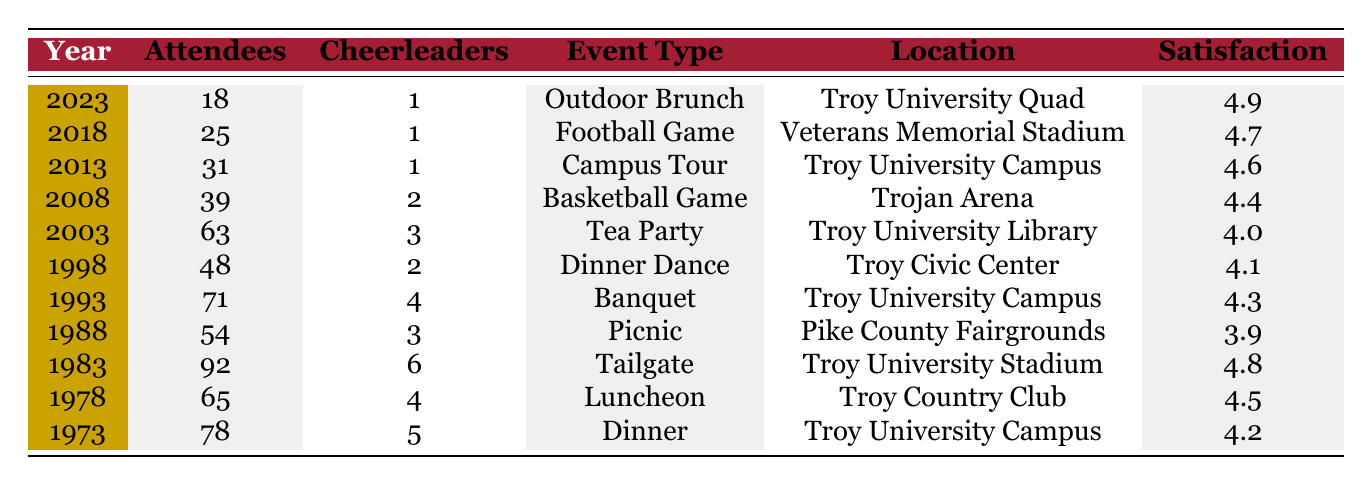What was the highest number of attendees at a reunion for the class of 1953? The data provides the number of attendees for each reunion year. Scanning through the table, the year 1983 has the highest number of attendees with 92.
Answer: 92 In which year did the reunion at Troy County Club take place? Referring to the table, the event at Troy Country Club occurred in 1978.
Answer: 1978 What was the average satisfaction score for the reunions held on campus (Troy University Campus)? The events held on the Troy University Campus occurred in 1973, 1993, and 2013. Their satisfaction scores are 4.2, 4.3, and 4.6 respectively. The average satisfaction is (4.2 + 4.3 + 4.6) / 3 = 4.3667, rounded to 4.37.
Answer: 4.37 Did the number of cheerleader attendees increase over the years? Checking the cheerleader attendees row by row shows that the numbers are 5, 4, 6, 3, 4, 2, 3, 2, 1, 1, and 1. The highest was 6 in 1983, and it generally decreased over the years to only 1 in the last three reunions, so it did not increase.
Answer: No What was the change in the number of overall attendees from the first reunion in 1973 to the last reunion in 2023? To find the change, subtract the number of attendees in 2023 (18) from those in 1973 (78). The difference is 78 - 18 = 60, indicating a significant decrease in attendance over these years.
Answer: 60 